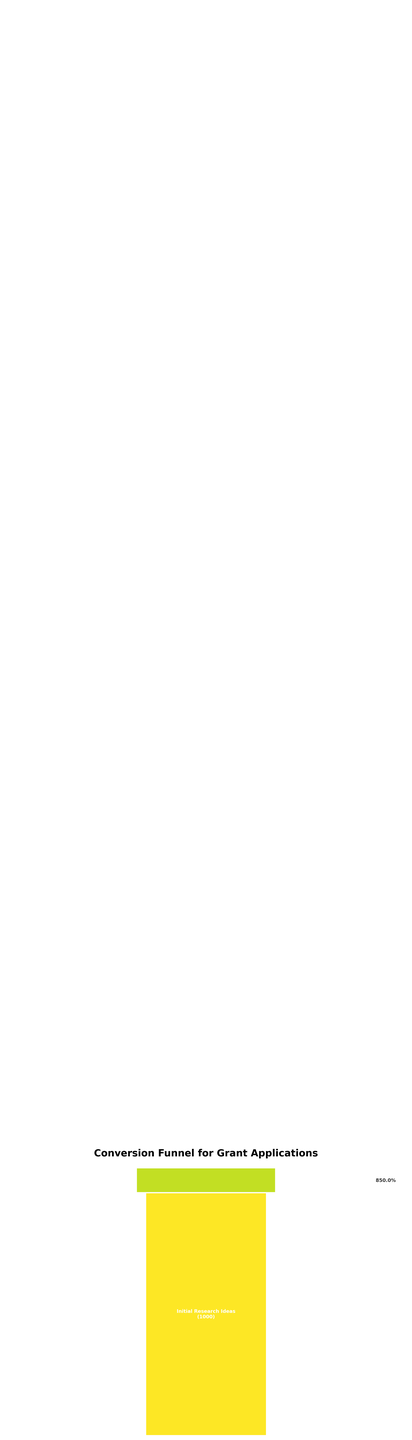what is the title of the funnel chart? The title of the funnel chart is displayed at the top of the figure.
Answer: Conversion Funnel for Grant Applications What is the final number of grant awarded applications? The number of grant awarded applications is displayed at the bottom of the funnel as the last stage.
Answer: 100 What percentage of applications passed from the Proposal Drafting stage to the Internal Review stage? Calculate the percentage of applications that moved from the Proposal Drafting stage (720) to the Internal Review stage (600) using the formula (600 / 720) * 100.
Answer: 83.3% How many stages are there in the grant application process shown in the funnel chart? Count the number of stages listed vertically in the funnel chart.
Answer: 11 What is the difference in the number of applications between the Initial Research Ideas stage and the Administrative Screening stage? Subtract the number of applications at the Administrative Screening stage (420) from the number of applications at the Initial Research Ideas stage (1000) to get the difference.
Answer: 580 Which stage has the highest drop in the number of applications compared to the previous stage? Compare the drop in application numbers between consecutive stages to determine the largest drop, which occurs between the Panel Evaluation (280) and Peer Review Process (350) stages, with a drop of 70.
Answer: Panel Evaluation What are the application numbers at the Peer Review Process and Panel Evaluation stages, and how much did they decrease by? The number of applications at the Peer Review Process stage is 350, and at the Panel Evaluation stage is 280. Subtract 280 from 350 to find the decrease.
Answer: 70 What percentage of initial research ideas reach the final proposal submission stage? Calculate the percentage using the numbers from the Initial Research Ideas stage (1000) and the Final Proposal Submission stage (450) with the formula (450 / 1000) * 100.
Answer: 45% What is the percentage decrease from the Internal Review stage to the Collaborator Agreements stage? Calculate the percentage decrease using the formula ((600 - 520) / 600) * 100 to find the decrease from the Internal Review stage to the Collaborator Agreements stage.
Answer: 13.3% How many total applications are lost from the Initial Research Ideas stage to the Grant Awarded stage? Subtract the number of applications at the Grant Awarded stage (100) from the number at the Initial Research Ideas stage (1000) to find the total number of applications lost.
Answer: 900 